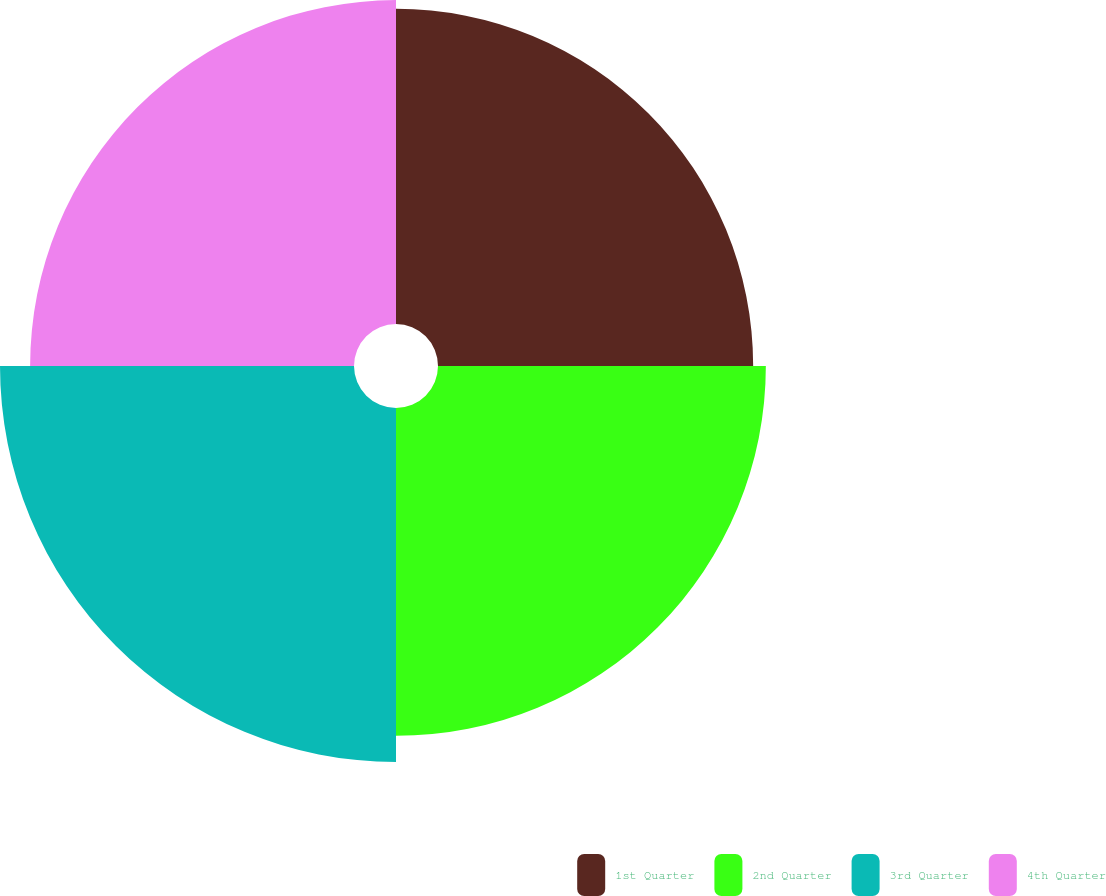Convert chart to OTSL. <chart><loc_0><loc_0><loc_500><loc_500><pie_chart><fcel>1st Quarter<fcel>2nd Quarter<fcel>3rd Quarter<fcel>4th Quarter<nl><fcel>23.86%<fcel>24.82%<fcel>26.8%<fcel>24.52%<nl></chart> 